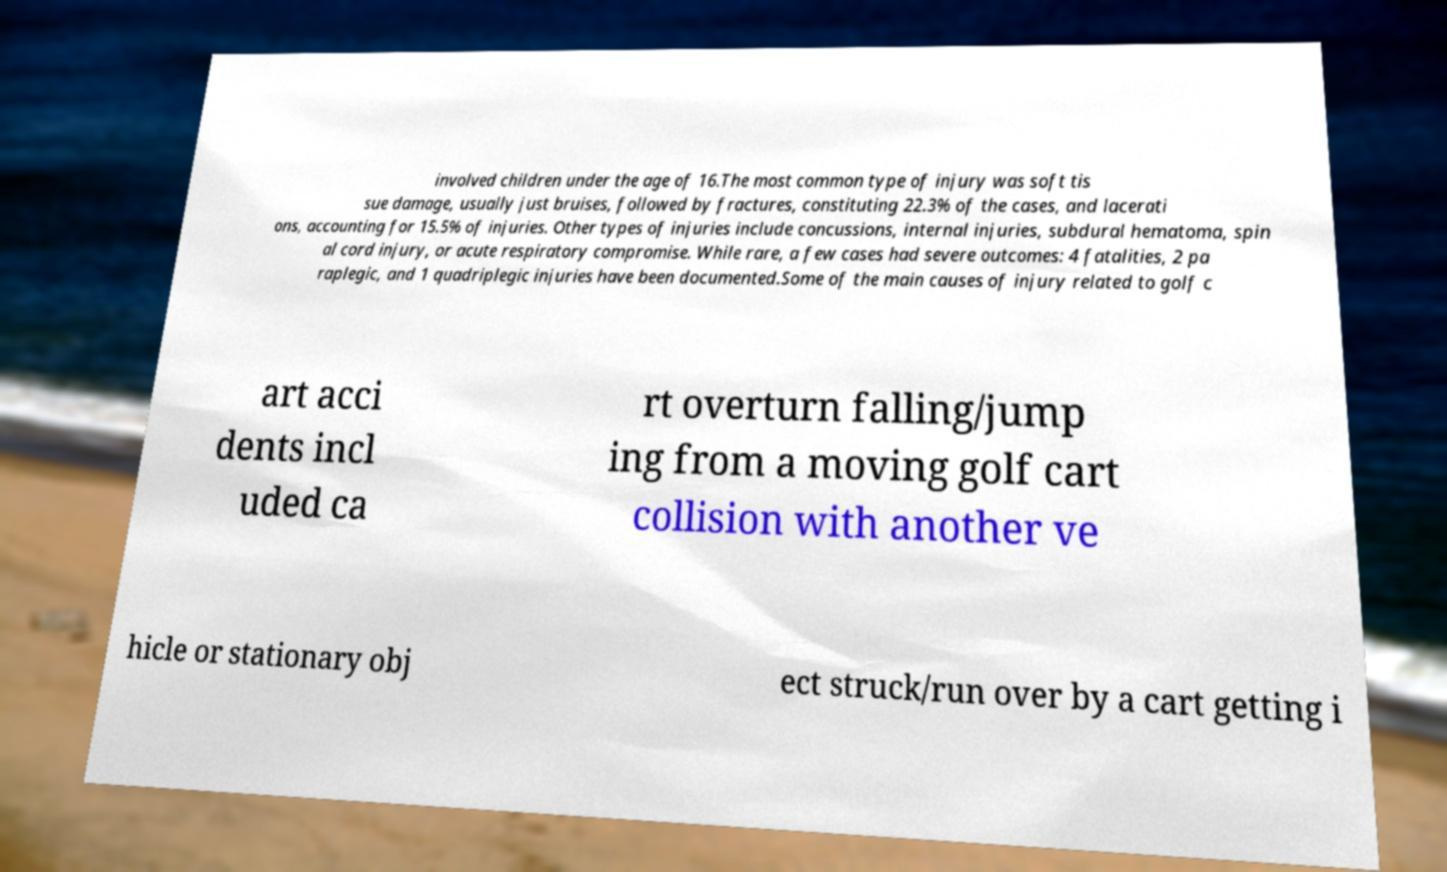I need the written content from this picture converted into text. Can you do that? involved children under the age of 16.The most common type of injury was soft tis sue damage, usually just bruises, followed by fractures, constituting 22.3% of the cases, and lacerati ons, accounting for 15.5% of injuries. Other types of injuries include concussions, internal injuries, subdural hematoma, spin al cord injury, or acute respiratory compromise. While rare, a few cases had severe outcomes: 4 fatalities, 2 pa raplegic, and 1 quadriplegic injuries have been documented.Some of the main causes of injury related to golf c art acci dents incl uded ca rt overturn falling/jump ing from a moving golf cart collision with another ve hicle or stationary obj ect struck/run over by a cart getting i 